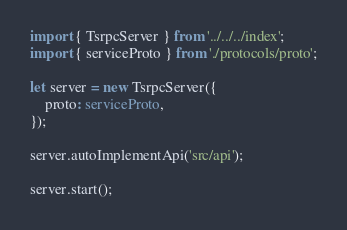<code> <loc_0><loc_0><loc_500><loc_500><_TypeScript_>import { TsrpcServer } from '../../../index';
import { serviceProto } from './protocols/proto';

let server = new TsrpcServer({
    proto: serviceProto,
});

server.autoImplementApi('src/api');

server.start();</code> 